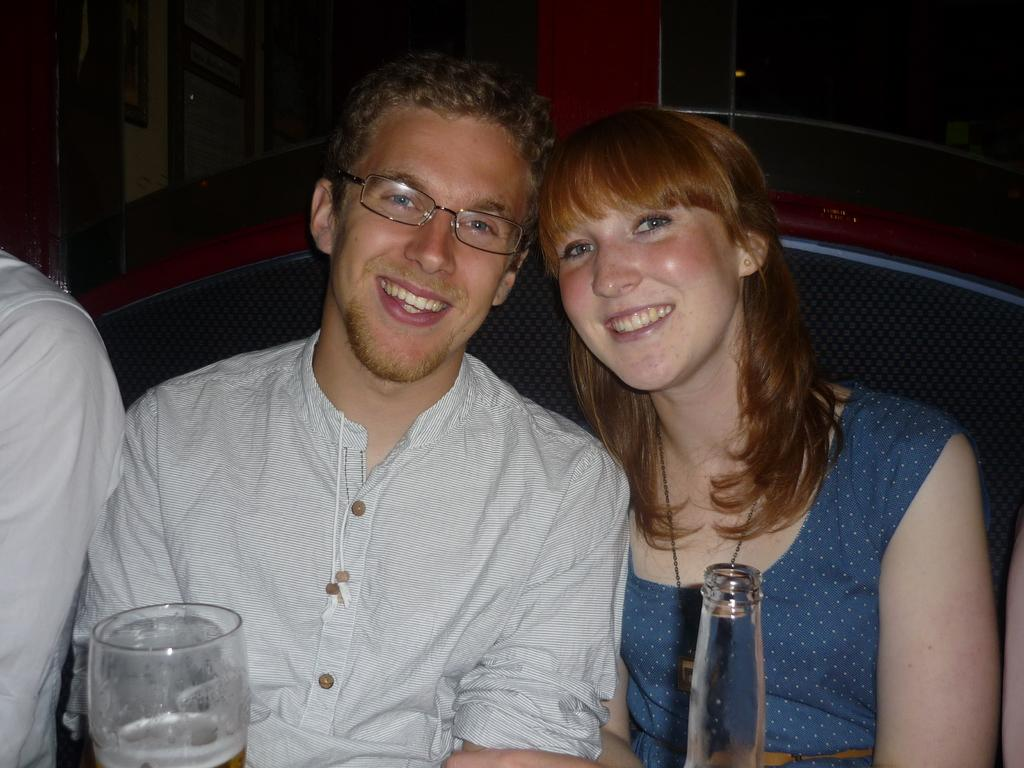What are the persons in the image doing? The persons in the image are sitting on the sofa. What is the facial expression of the persons? The persons are smiling. What objects can be seen in the image related to drinks? There is a glass and a bottle in the image. What can be seen in the background of the image? There is a wall in the background of the image, and frames are present on the wall. Can you see any keys or shoes in the image? There are no keys or shoes visible in the image. Are there any snails crawling on the sofa in the image? There are no snails present in the image. 